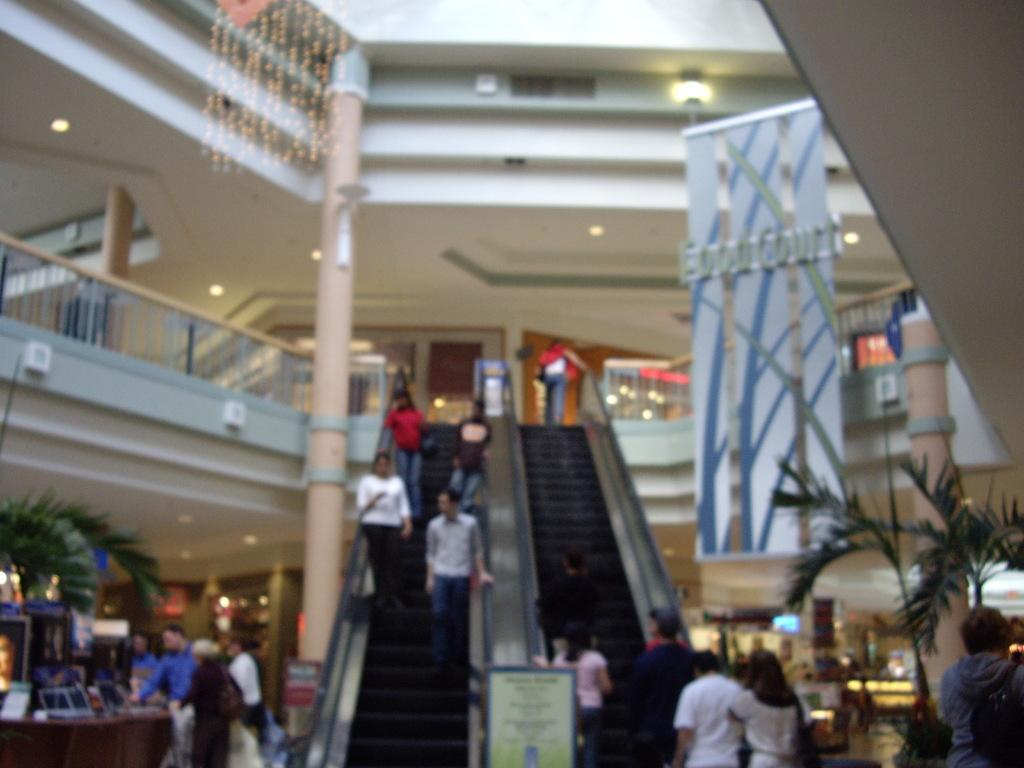What type of location is depicted in the image? The image is an inside view of a mall. What architectural features can be seen in the image? There are escalators, pillars, walls, railings, and a ceiling with lights visible in the image. What type of vegetation is present in the image? There are plants in the image. What type of signage can be seen in the image? There is a hoarding and a board in the image. What else can be seen in the image? There is a group of people and various objects visible in the image. How many eyes can be seen on the sock in the image? There is no sock present in the image, and therefore no eyes can be seen on it. 